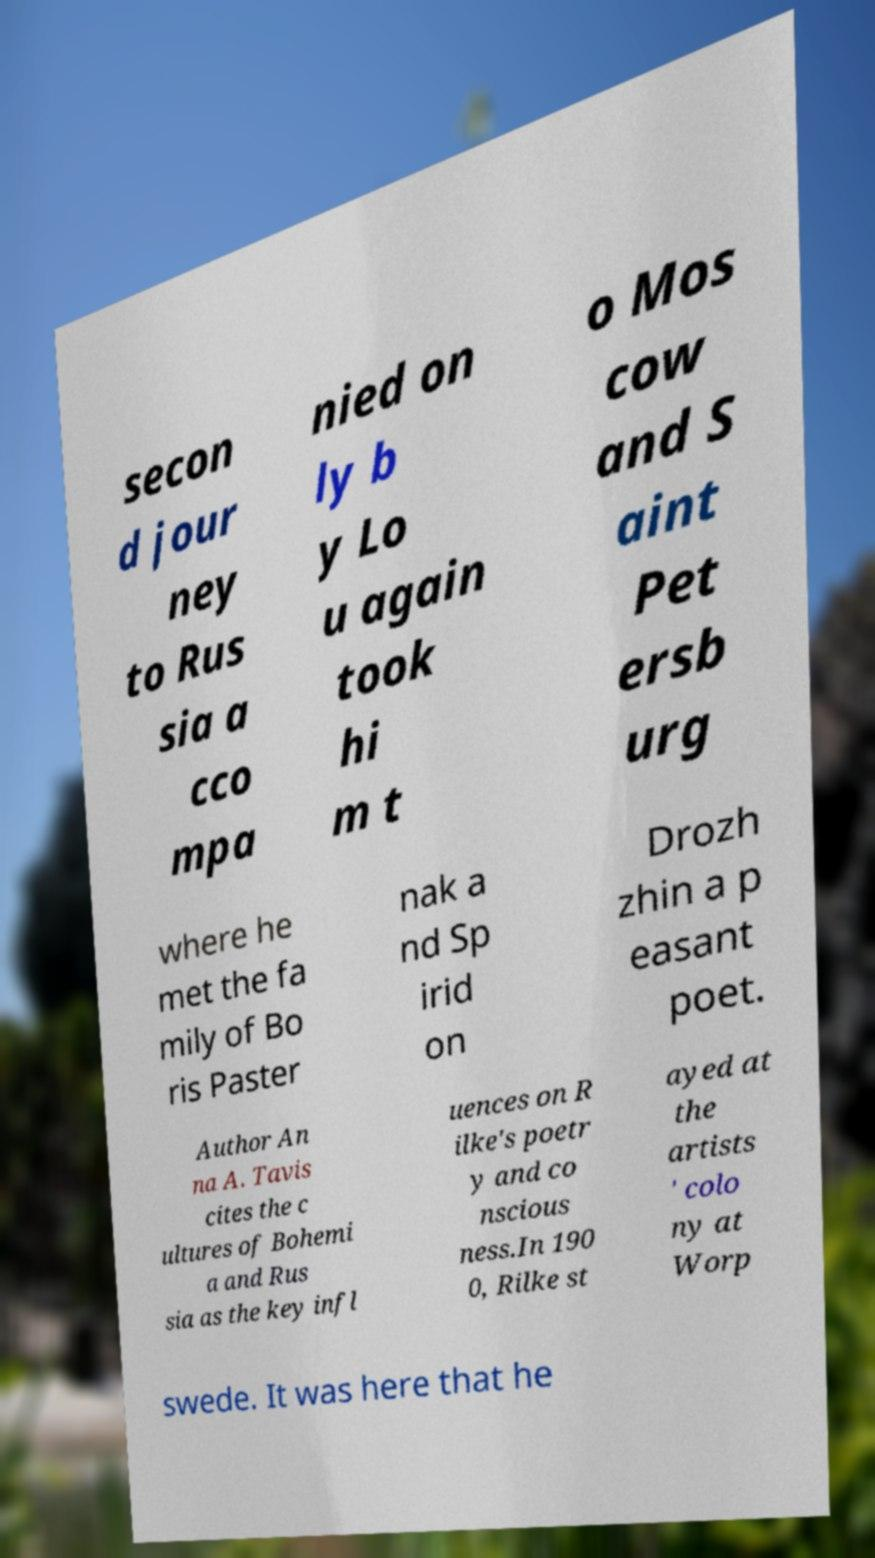For documentation purposes, I need the text within this image transcribed. Could you provide that? secon d jour ney to Rus sia a cco mpa nied on ly b y Lo u again took hi m t o Mos cow and S aint Pet ersb urg where he met the fa mily of Bo ris Paster nak a nd Sp irid on Drozh zhin a p easant poet. Author An na A. Tavis cites the c ultures of Bohemi a and Rus sia as the key infl uences on R ilke's poetr y and co nscious ness.In 190 0, Rilke st ayed at the artists ' colo ny at Worp swede. It was here that he 